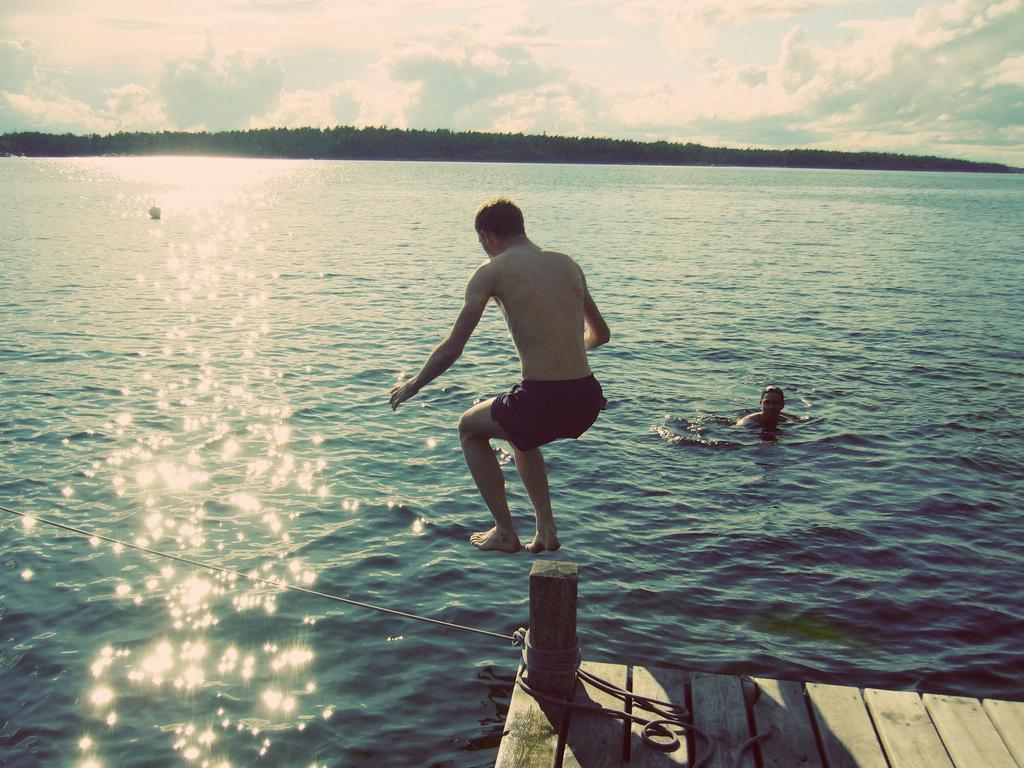Describe this image in one or two sentences. In this picture we can see a rope on a wooden platform, two men where a man in the water and a person is jumping and in the background we can see the sky with clouds. 